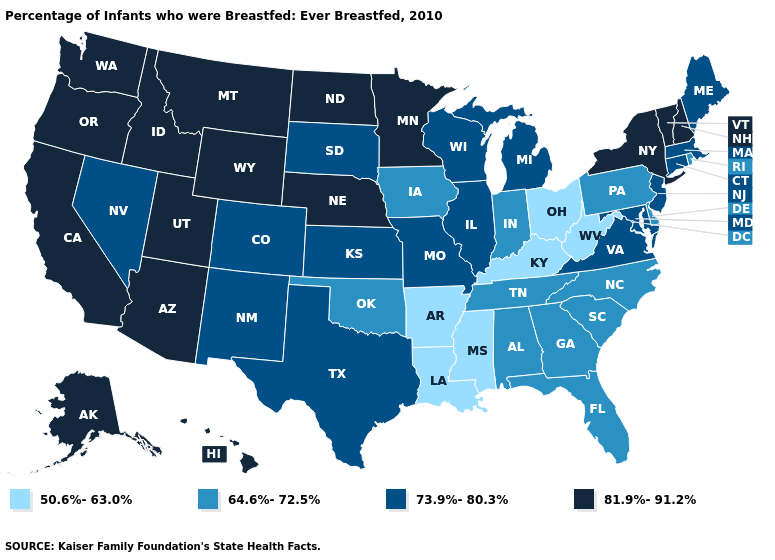What is the value of Tennessee?
Give a very brief answer. 64.6%-72.5%. Does the map have missing data?
Short answer required. No. What is the value of Pennsylvania?
Be succinct. 64.6%-72.5%. Does Massachusetts have a higher value than Maryland?
Give a very brief answer. No. Name the states that have a value in the range 50.6%-63.0%?
Answer briefly. Arkansas, Kentucky, Louisiana, Mississippi, Ohio, West Virginia. What is the highest value in the USA?
Quick response, please. 81.9%-91.2%. Which states hav the highest value in the MidWest?
Concise answer only. Minnesota, Nebraska, North Dakota. Does New Mexico have a lower value than Alabama?
Keep it brief. No. Does Montana have the lowest value in the USA?
Quick response, please. No. Name the states that have a value in the range 64.6%-72.5%?
Give a very brief answer. Alabama, Delaware, Florida, Georgia, Indiana, Iowa, North Carolina, Oklahoma, Pennsylvania, Rhode Island, South Carolina, Tennessee. What is the value of Missouri?
Short answer required. 73.9%-80.3%. What is the highest value in states that border Arkansas?
Answer briefly. 73.9%-80.3%. Does the map have missing data?
Quick response, please. No. Name the states that have a value in the range 73.9%-80.3%?
Short answer required. Colorado, Connecticut, Illinois, Kansas, Maine, Maryland, Massachusetts, Michigan, Missouri, Nevada, New Jersey, New Mexico, South Dakota, Texas, Virginia, Wisconsin. Does Indiana have the lowest value in the MidWest?
Be succinct. No. 